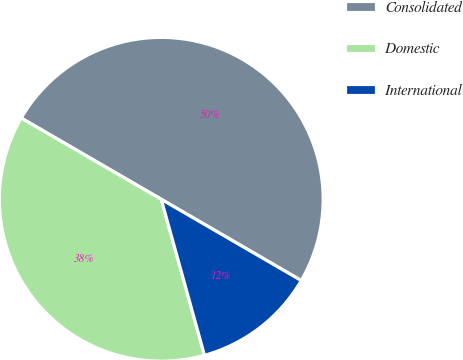Convert chart. <chart><loc_0><loc_0><loc_500><loc_500><pie_chart><fcel>Consolidated<fcel>Domestic<fcel>International<nl><fcel>50.0%<fcel>37.67%<fcel>12.33%<nl></chart> 